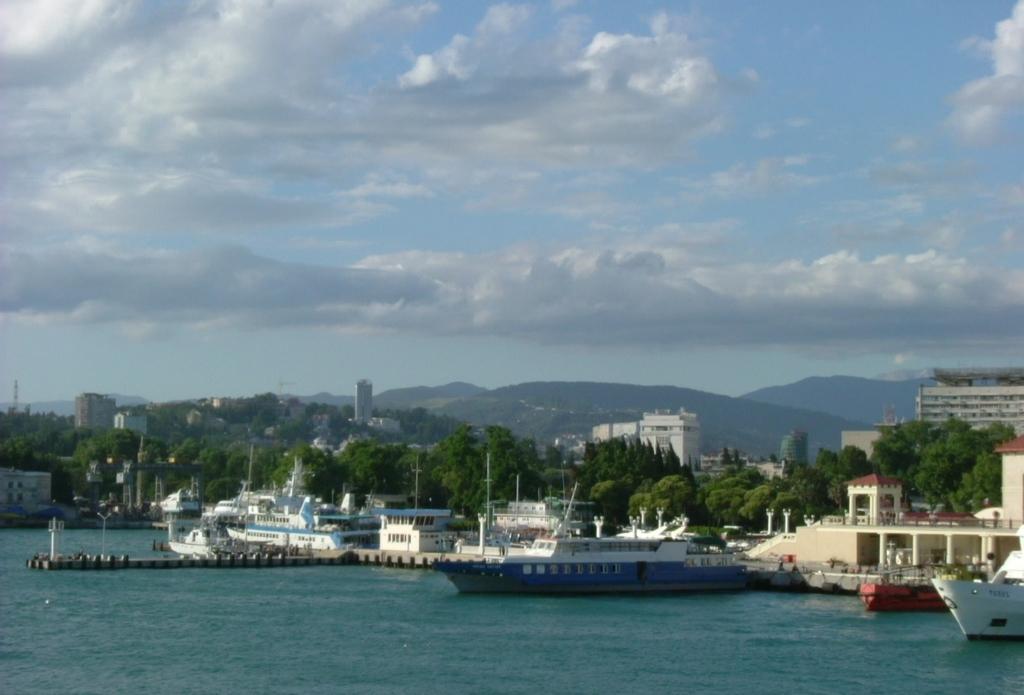How would you summarize this image in a sentence or two? In this image we can see ships on the water, walkway bridge, poles, trees, buildings, hills and sky with clouds. 